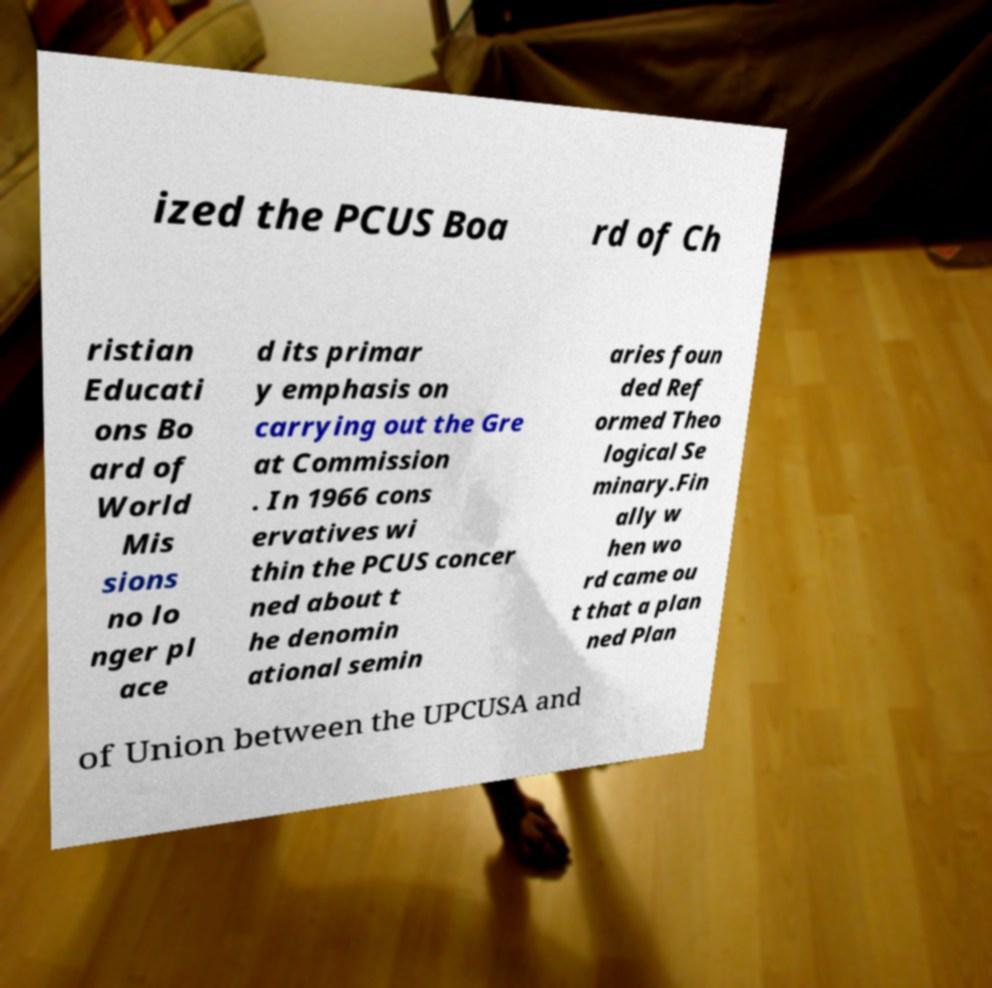Could you extract and type out the text from this image? ized the PCUS Boa rd of Ch ristian Educati ons Bo ard of World Mis sions no lo nger pl ace d its primar y emphasis on carrying out the Gre at Commission . In 1966 cons ervatives wi thin the PCUS concer ned about t he denomin ational semin aries foun ded Ref ormed Theo logical Se minary.Fin ally w hen wo rd came ou t that a plan ned Plan of Union between the UPCUSA and 